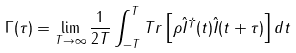<formula> <loc_0><loc_0><loc_500><loc_500>\Gamma ( \tau ) = \lim _ { T \rightarrow \infty } \frac { 1 } { 2 T } \int _ { - T } ^ { T } T r \left [ \rho \hat { I } ^ { \dagger } ( t ) \hat { I } ( t + \tau ) \right ] d t</formula> 